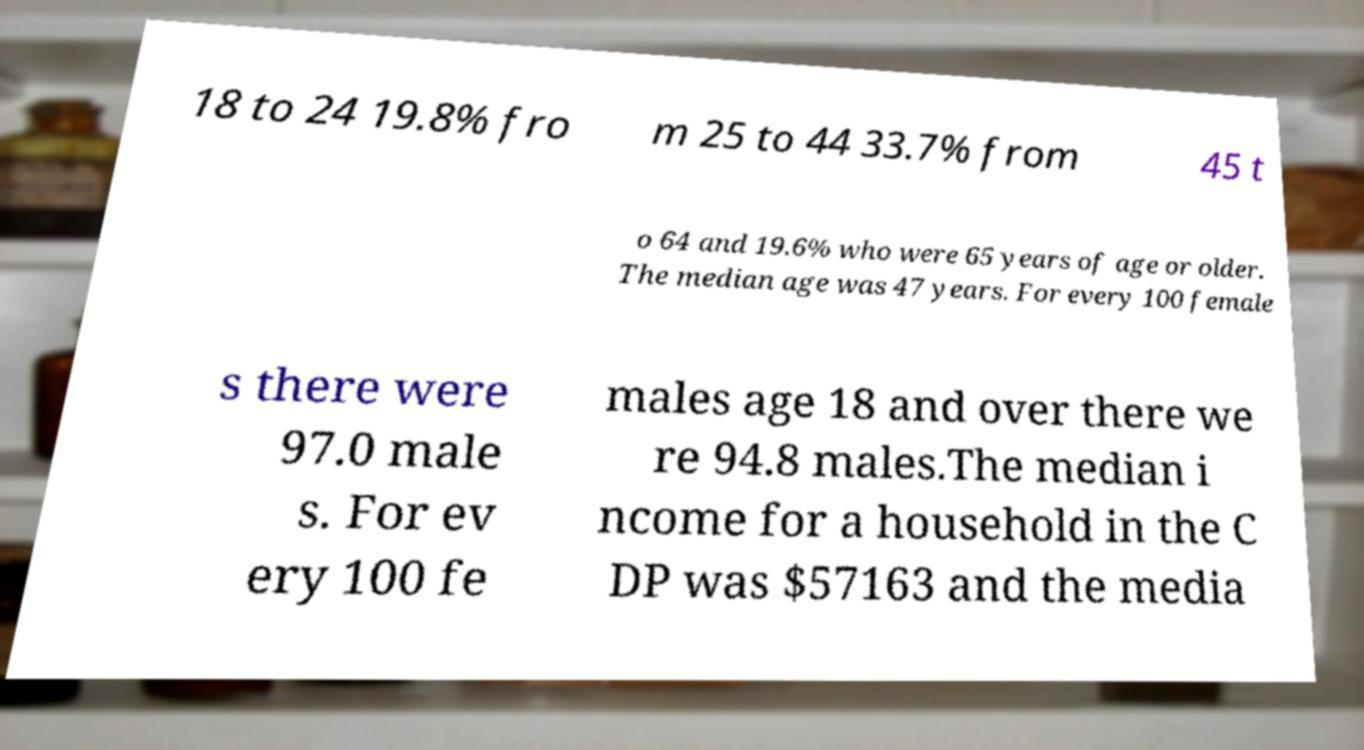I need the written content from this picture converted into text. Can you do that? 18 to 24 19.8% fro m 25 to 44 33.7% from 45 t o 64 and 19.6% who were 65 years of age or older. The median age was 47 years. For every 100 female s there were 97.0 male s. For ev ery 100 fe males age 18 and over there we re 94.8 males.The median i ncome for a household in the C DP was $57163 and the media 